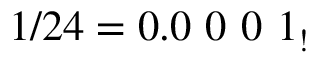Convert formula to latex. <formula><loc_0><loc_0><loc_500><loc_500>1 / 2 4 = 0 . 0 \ 0 \ 0 \ 1 _ { ! }</formula> 